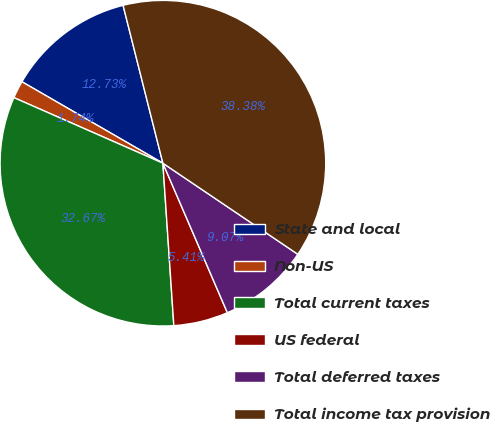<chart> <loc_0><loc_0><loc_500><loc_500><pie_chart><fcel>State and local<fcel>Non-US<fcel>Total current taxes<fcel>US federal<fcel>Total deferred taxes<fcel>Total income tax provision<nl><fcel>12.73%<fcel>1.74%<fcel>32.67%<fcel>5.41%<fcel>9.07%<fcel>38.38%<nl></chart> 